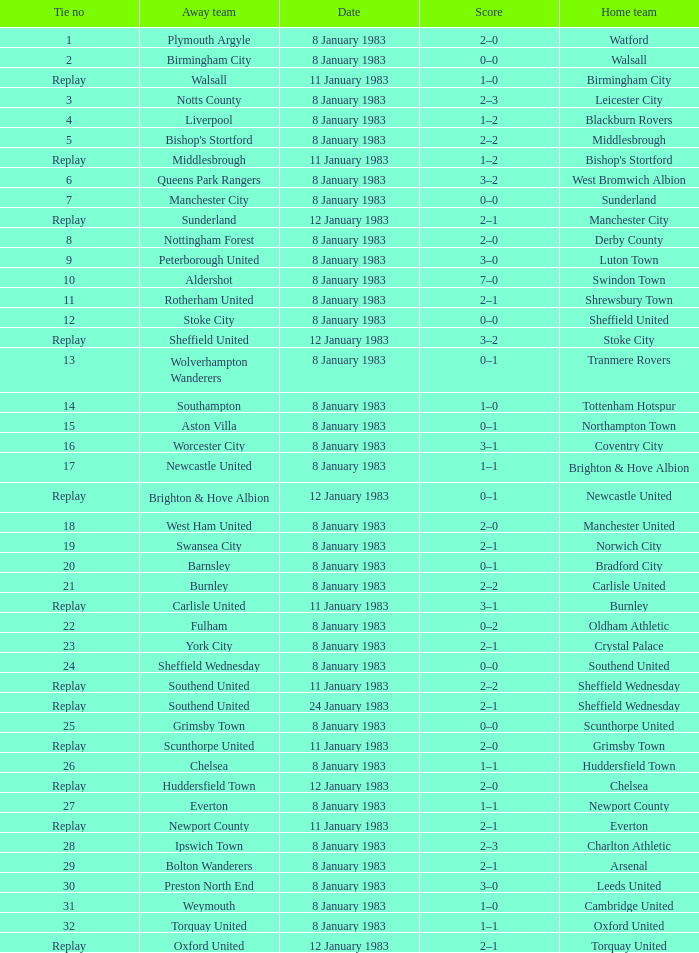On what date was Tie #26 played? 8 January 1983. 